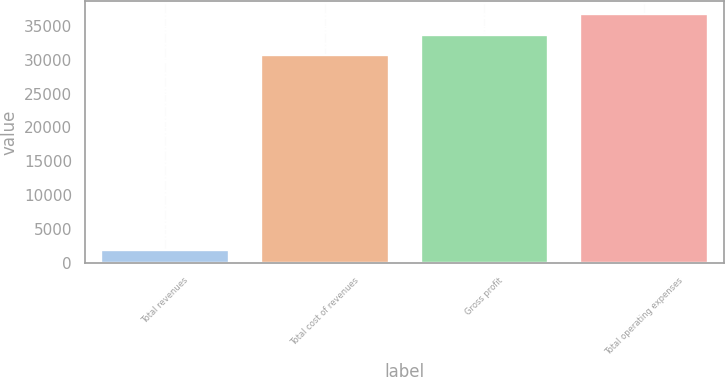Convert chart. <chart><loc_0><loc_0><loc_500><loc_500><bar_chart><fcel>Total revenues<fcel>Total cost of revenues<fcel>Gross profit<fcel>Total operating expenses<nl><fcel>1833<fcel>30650<fcel>33715<fcel>36780<nl></chart> 